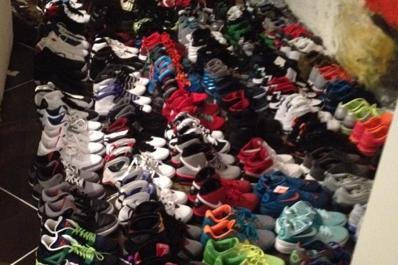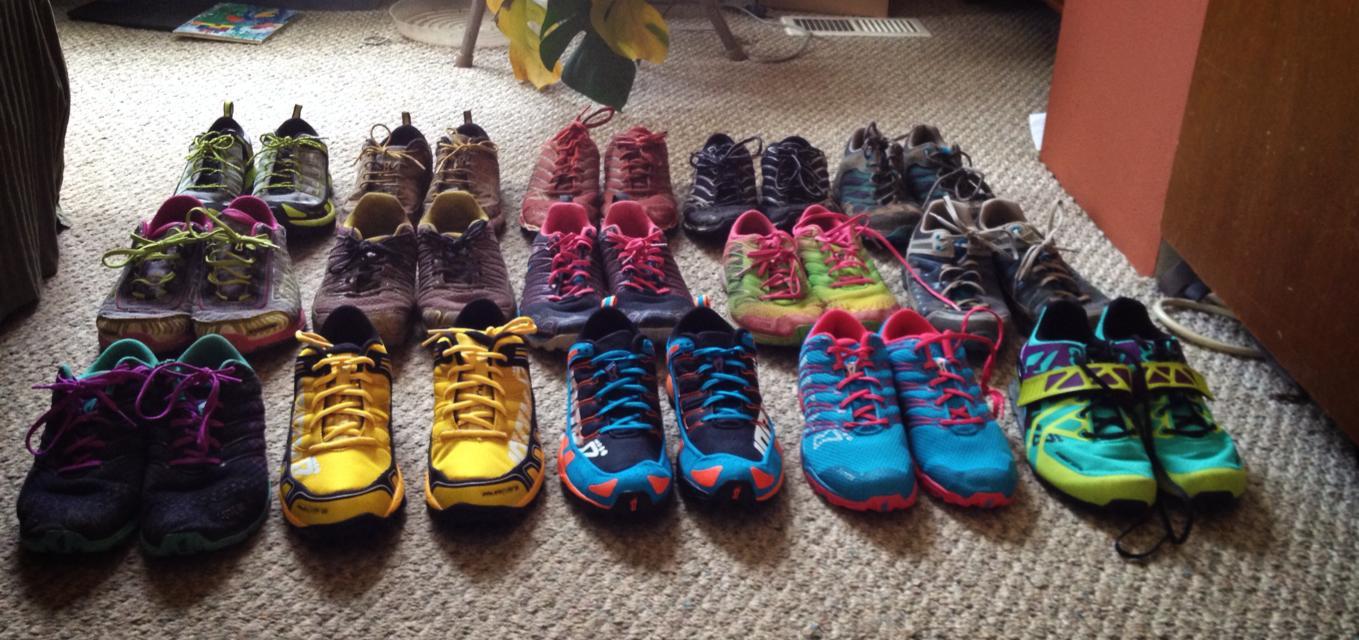The first image is the image on the left, the second image is the image on the right. Evaluate the accuracy of this statement regarding the images: "An image shows two horizontal rows of shoes sitting on the grass.". Is it true? Answer yes or no. No. The first image is the image on the left, the second image is the image on the right. Analyze the images presented: Is the assertion "Shoes are piled on the grass in at least one of the images." valid? Answer yes or no. No. 